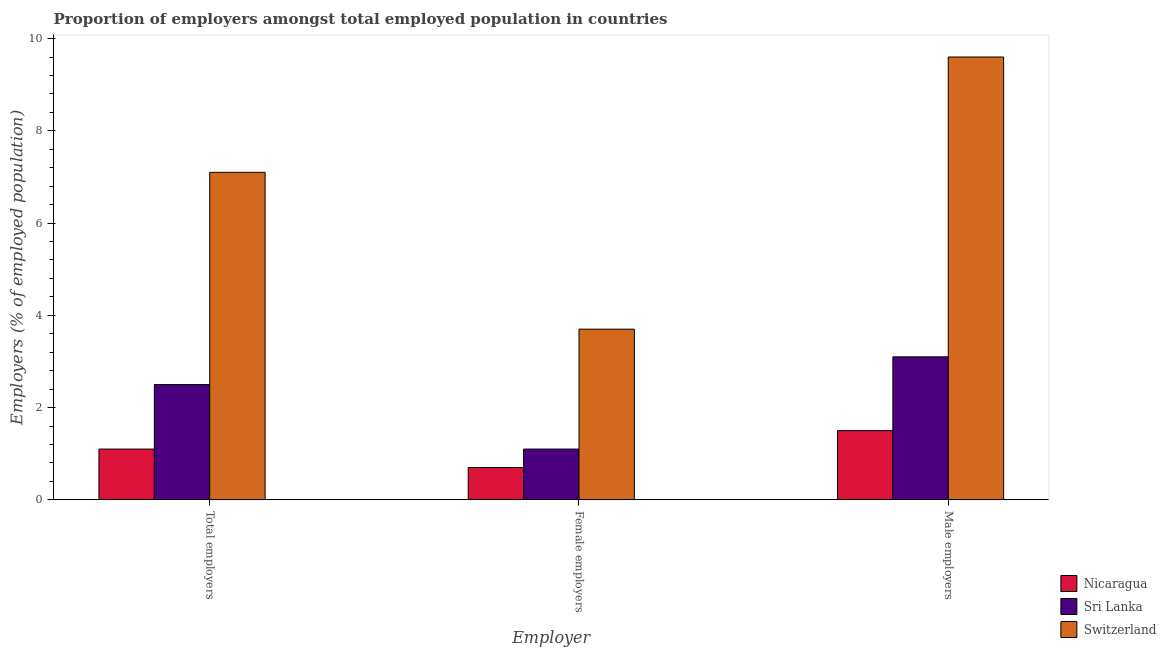How many bars are there on the 1st tick from the left?
Make the answer very short. 3. What is the label of the 1st group of bars from the left?
Give a very brief answer. Total employers. What is the percentage of female employers in Sri Lanka?
Offer a terse response. 1.1. Across all countries, what is the maximum percentage of female employers?
Give a very brief answer. 3.7. In which country was the percentage of female employers maximum?
Offer a very short reply. Switzerland. In which country was the percentage of total employers minimum?
Your answer should be very brief. Nicaragua. What is the total percentage of total employers in the graph?
Ensure brevity in your answer.  10.7. What is the difference between the percentage of female employers in Switzerland and that in Nicaragua?
Offer a very short reply. 3. What is the difference between the percentage of female employers in Switzerland and the percentage of male employers in Nicaragua?
Make the answer very short. 2.2. What is the average percentage of total employers per country?
Provide a succinct answer. 3.57. What is the difference between the percentage of total employers and percentage of female employers in Sri Lanka?
Keep it short and to the point. 1.4. In how many countries, is the percentage of female employers greater than 6 %?
Your answer should be compact. 0. What is the ratio of the percentage of total employers in Nicaragua to that in Switzerland?
Keep it short and to the point. 0.15. Is the difference between the percentage of female employers in Switzerland and Nicaragua greater than the difference between the percentage of total employers in Switzerland and Nicaragua?
Your answer should be compact. No. What is the difference between the highest and the second highest percentage of total employers?
Provide a succinct answer. 4.6. What is the difference between the highest and the lowest percentage of female employers?
Your answer should be very brief. 3. Is the sum of the percentage of female employers in Sri Lanka and Switzerland greater than the maximum percentage of male employers across all countries?
Your answer should be very brief. No. What does the 3rd bar from the left in Total employers represents?
Give a very brief answer. Switzerland. What does the 2nd bar from the right in Female employers represents?
Your answer should be compact. Sri Lanka. Is it the case that in every country, the sum of the percentage of total employers and percentage of female employers is greater than the percentage of male employers?
Ensure brevity in your answer.  Yes. How many bars are there?
Ensure brevity in your answer.  9. Are all the bars in the graph horizontal?
Provide a short and direct response. No. Are the values on the major ticks of Y-axis written in scientific E-notation?
Keep it short and to the point. No. Does the graph contain any zero values?
Provide a short and direct response. No. Where does the legend appear in the graph?
Give a very brief answer. Bottom right. How many legend labels are there?
Keep it short and to the point. 3. What is the title of the graph?
Your answer should be very brief. Proportion of employers amongst total employed population in countries. What is the label or title of the X-axis?
Make the answer very short. Employer. What is the label or title of the Y-axis?
Your answer should be very brief. Employers (% of employed population). What is the Employers (% of employed population) in Nicaragua in Total employers?
Offer a very short reply. 1.1. What is the Employers (% of employed population) of Switzerland in Total employers?
Provide a short and direct response. 7.1. What is the Employers (% of employed population) in Nicaragua in Female employers?
Provide a short and direct response. 0.7. What is the Employers (% of employed population) of Sri Lanka in Female employers?
Ensure brevity in your answer.  1.1. What is the Employers (% of employed population) of Switzerland in Female employers?
Keep it short and to the point. 3.7. What is the Employers (% of employed population) of Sri Lanka in Male employers?
Offer a very short reply. 3.1. What is the Employers (% of employed population) of Switzerland in Male employers?
Offer a very short reply. 9.6. Across all Employer, what is the maximum Employers (% of employed population) in Sri Lanka?
Provide a succinct answer. 3.1. Across all Employer, what is the maximum Employers (% of employed population) in Switzerland?
Your response must be concise. 9.6. Across all Employer, what is the minimum Employers (% of employed population) in Nicaragua?
Your answer should be compact. 0.7. Across all Employer, what is the minimum Employers (% of employed population) in Sri Lanka?
Offer a terse response. 1.1. Across all Employer, what is the minimum Employers (% of employed population) of Switzerland?
Keep it short and to the point. 3.7. What is the total Employers (% of employed population) in Sri Lanka in the graph?
Offer a terse response. 6.7. What is the total Employers (% of employed population) of Switzerland in the graph?
Give a very brief answer. 20.4. What is the difference between the Employers (% of employed population) of Nicaragua in Total employers and that in Female employers?
Make the answer very short. 0.4. What is the difference between the Employers (% of employed population) in Sri Lanka in Total employers and that in Female employers?
Ensure brevity in your answer.  1.4. What is the difference between the Employers (% of employed population) in Nicaragua in Total employers and that in Male employers?
Keep it short and to the point. -0.4. What is the difference between the Employers (% of employed population) of Sri Lanka in Female employers and that in Male employers?
Ensure brevity in your answer.  -2. What is the difference between the Employers (% of employed population) in Nicaragua in Total employers and the Employers (% of employed population) in Sri Lanka in Female employers?
Offer a very short reply. 0. What is the difference between the Employers (% of employed population) of Nicaragua in Total employers and the Employers (% of employed population) of Switzerland in Female employers?
Make the answer very short. -2.6. What is the difference between the Employers (% of employed population) of Sri Lanka in Total employers and the Employers (% of employed population) of Switzerland in Female employers?
Provide a succinct answer. -1.2. What is the difference between the Employers (% of employed population) of Nicaragua in Total employers and the Employers (% of employed population) of Switzerland in Male employers?
Give a very brief answer. -8.5. What is the average Employers (% of employed population) of Sri Lanka per Employer?
Provide a succinct answer. 2.23. What is the average Employers (% of employed population) in Switzerland per Employer?
Your response must be concise. 6.8. What is the difference between the Employers (% of employed population) of Nicaragua and Employers (% of employed population) of Sri Lanka in Total employers?
Offer a terse response. -1.4. What is the difference between the Employers (% of employed population) of Nicaragua and Employers (% of employed population) of Switzerland in Total employers?
Provide a succinct answer. -6. What is the difference between the Employers (% of employed population) of Nicaragua and Employers (% of employed population) of Sri Lanka in Female employers?
Keep it short and to the point. -0.4. What is the difference between the Employers (% of employed population) of Sri Lanka and Employers (% of employed population) of Switzerland in Female employers?
Provide a short and direct response. -2.6. What is the difference between the Employers (% of employed population) of Nicaragua and Employers (% of employed population) of Sri Lanka in Male employers?
Your answer should be very brief. -1.6. What is the difference between the Employers (% of employed population) in Nicaragua and Employers (% of employed population) in Switzerland in Male employers?
Keep it short and to the point. -8.1. What is the difference between the Employers (% of employed population) in Sri Lanka and Employers (% of employed population) in Switzerland in Male employers?
Provide a short and direct response. -6.5. What is the ratio of the Employers (% of employed population) in Nicaragua in Total employers to that in Female employers?
Make the answer very short. 1.57. What is the ratio of the Employers (% of employed population) of Sri Lanka in Total employers to that in Female employers?
Make the answer very short. 2.27. What is the ratio of the Employers (% of employed population) in Switzerland in Total employers to that in Female employers?
Make the answer very short. 1.92. What is the ratio of the Employers (% of employed population) in Nicaragua in Total employers to that in Male employers?
Your response must be concise. 0.73. What is the ratio of the Employers (% of employed population) in Sri Lanka in Total employers to that in Male employers?
Give a very brief answer. 0.81. What is the ratio of the Employers (% of employed population) of Switzerland in Total employers to that in Male employers?
Your answer should be compact. 0.74. What is the ratio of the Employers (% of employed population) in Nicaragua in Female employers to that in Male employers?
Provide a short and direct response. 0.47. What is the ratio of the Employers (% of employed population) in Sri Lanka in Female employers to that in Male employers?
Ensure brevity in your answer.  0.35. What is the ratio of the Employers (% of employed population) of Switzerland in Female employers to that in Male employers?
Your response must be concise. 0.39. What is the difference between the highest and the second highest Employers (% of employed population) in Nicaragua?
Your answer should be compact. 0.4. What is the difference between the highest and the second highest Employers (% of employed population) in Switzerland?
Your answer should be very brief. 2.5. What is the difference between the highest and the lowest Employers (% of employed population) in Nicaragua?
Offer a very short reply. 0.8. 